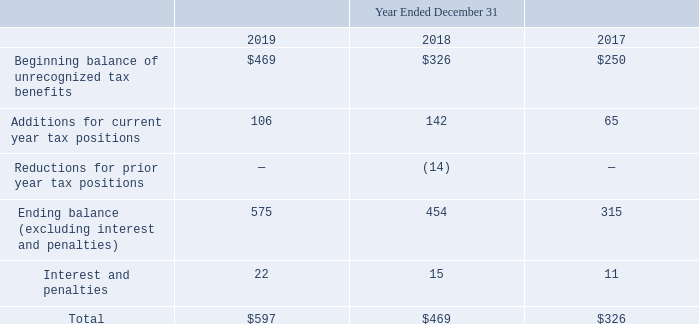The following changes occurred in the amount of unrecognized tax benefits (in thousands):
For the year ended December 31, 2019, 2018 and 2017, the Company has recorded income tax expense of $128,000, $143,000 and $76,000, respectively, related to uncertain tax positions. The Company’s policy is to recognize potential interest and penalties related to unrecognized tax benefits associated with uncertain tax positions, if any, in the income tax provision. At December 31, 2019, 2018 and 2017, the Company had accrued $22,000, $15,000 and $11,000 in interest and penalties related to uncertain tax positions.
The Company is subject to taxation in the United States and various states along with other foreign countries. The Company has not been notified that it is under audit by the IRS or any state or foreign taxing authorities, however, due to the presence of NOL carryforwards, all of the income tax years remain open for examination in each of these jurisdictions. The Company does not believe that it is reasonably possible that the total amount of unrecognized tax benefits will significantly increase or decrease in the next 12 months.
Deferred income taxes have not been provided for undistributed earnings of the Company’s consolidated foreign subsidiaries because of the Company’s intent to reinvest such earnings indefinitely in active foreign operations. At December 31, 2019, the Company had $0.6 million in unremitted earnings that were permanently reinvested related to its consolidated foreign subsidiaries.
What was the income tax expense in 2019,2018 and 2017 respectively? $128,000, $143,000, $76,000. What was the accrued interest and penalties in 2019, 2018 and 2017 respectively? $22,000, $15,000, $11,000. What was the company's unremitted earnings in 2019? $0.6 million. What was the change in the Additions for current year tax positions from 2018 to 2019?
Answer scale should be: thousand. 106 - 142
Answer: -36. In which year was Interest and penalties less than 20 thousand? Locate and analyze interest and penalties in row 8
answer: 2018, 2017. What was the average Reductions for prior year tax positions from 2017-2019?
Answer scale should be: thousand. -(0 + 14 + 0) / 3
Answer: -4.67. 